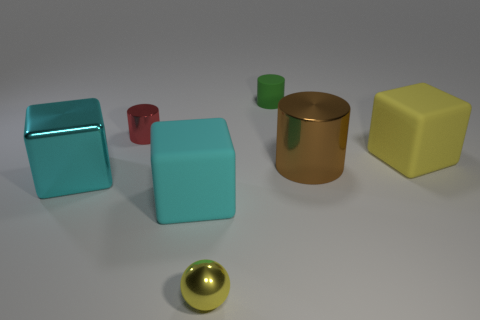What is the size of the other matte object that is the same shape as the big cyan matte thing?
Ensure brevity in your answer.  Large. Are there any other things that are the same material as the small green object?
Make the answer very short. Yes. Is the size of the shiny cylinder to the right of the green cylinder the same as the matte block that is left of the yellow ball?
Provide a short and direct response. Yes. How many big things are blue shiny balls or matte cylinders?
Make the answer very short. 0. What number of cylinders are both behind the large brown cylinder and in front of the small green thing?
Provide a short and direct response. 1. Are the brown cylinder and the large cyan thing that is on the right side of the small red cylinder made of the same material?
Provide a short and direct response. No. What number of cyan objects are either matte objects or large things?
Keep it short and to the point. 2. Are there any red things that have the same size as the matte cylinder?
Provide a succinct answer. Yes. What material is the object that is on the right side of the cylinder that is in front of the big object to the right of the big brown shiny cylinder made of?
Offer a very short reply. Rubber. Are there the same number of tiny matte cylinders behind the tiny yellow object and yellow things?
Your response must be concise. No. 